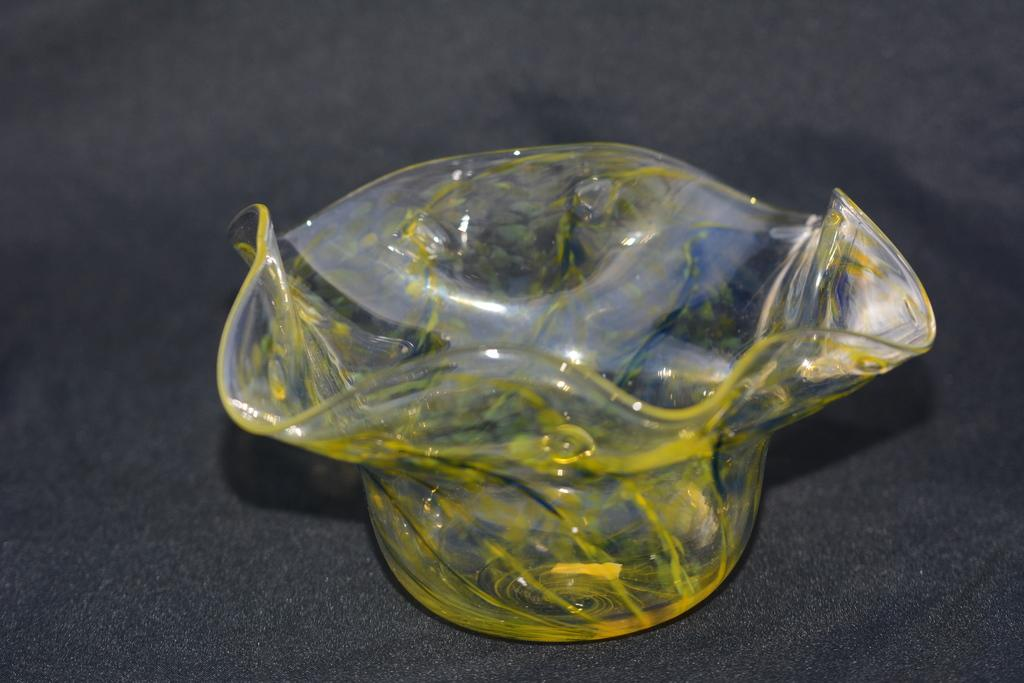What type of container is visible in the image? There is a glass bowl in the image. What color is the background of the image? The background of the image is grey in color. What theory is being discussed by the fireman in the image? There is no fireman or discussion of a theory present in the image. 